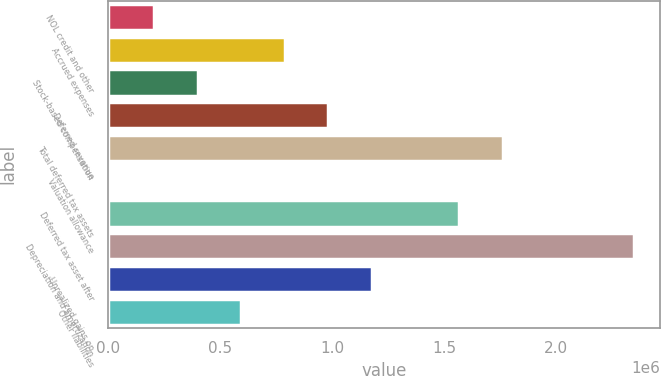Convert chart to OTSL. <chart><loc_0><loc_0><loc_500><loc_500><bar_chart><fcel>NOL credit and other<fcel>Accrued expenses<fcel>Stock-based compensation<fcel>Deferred revenue<fcel>Total deferred tax assets<fcel>Valuation allowance<fcel>Deferred tax asset after<fcel>Depreciation and amortization<fcel>Unrealized gains on<fcel>Other liabilities<nl><fcel>204410<fcel>789094<fcel>399304<fcel>983988<fcel>1.76357e+06<fcel>9515<fcel>1.56867e+06<fcel>2.34825e+06<fcel>1.17888e+06<fcel>594199<nl></chart> 